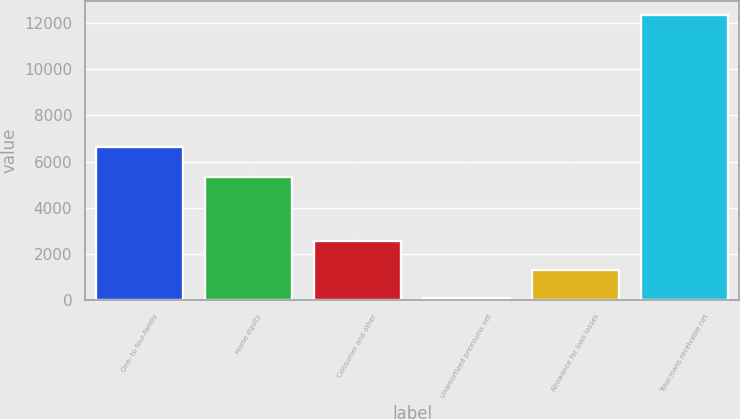Convert chart to OTSL. <chart><loc_0><loc_0><loc_500><loc_500><bar_chart><fcel>One- to four-family<fcel>Home equity<fcel>Consumer and other<fcel>Unamortized premiums net<fcel>Allowance for loan losses<fcel>Total loans receivable net<nl><fcel>6615.8<fcel>5328.7<fcel>2544.88<fcel>97.9<fcel>1321.39<fcel>12332.8<nl></chart> 